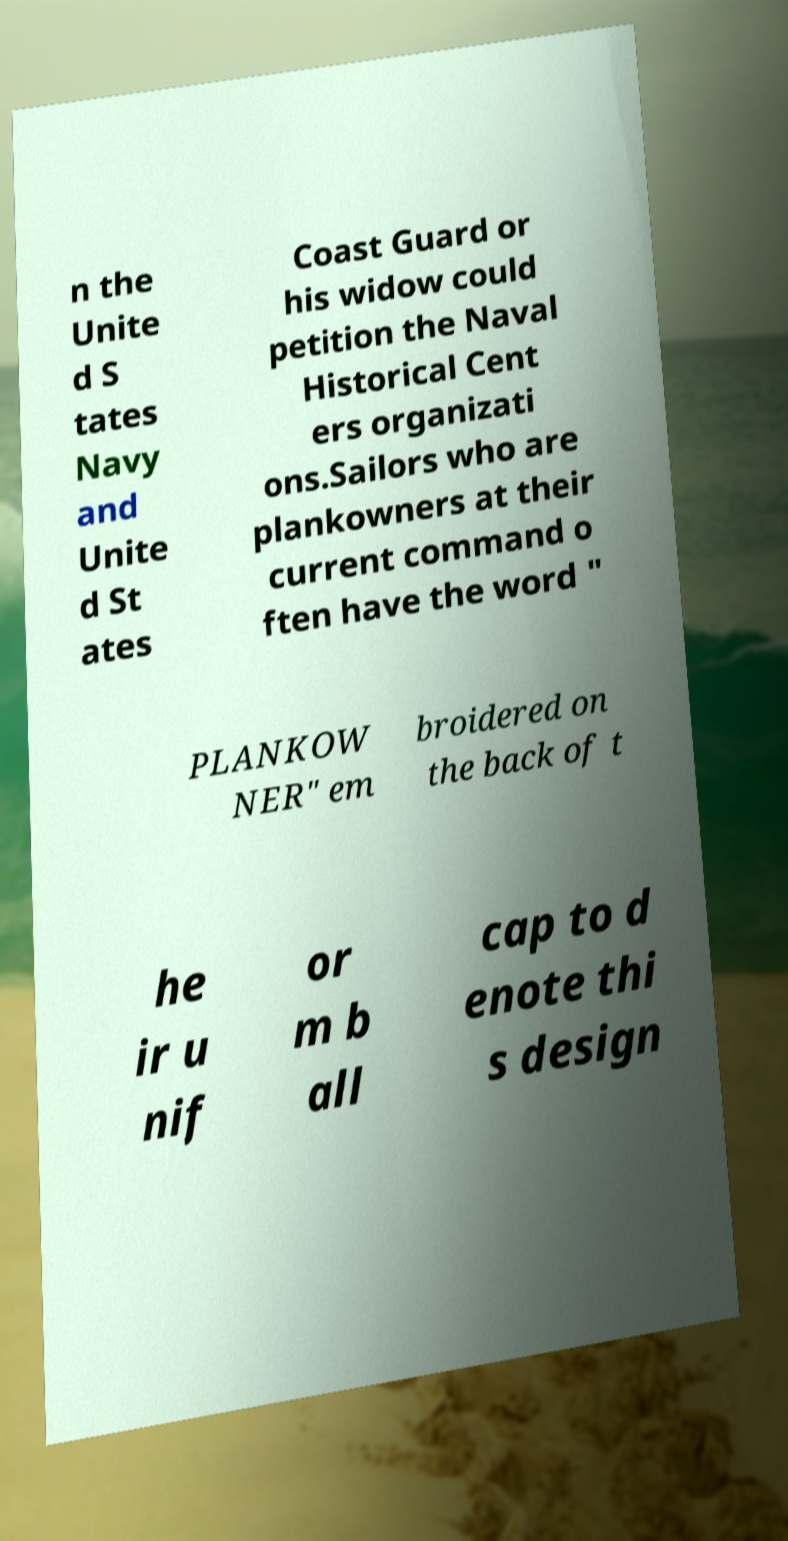Can you read and provide the text displayed in the image?This photo seems to have some interesting text. Can you extract and type it out for me? n the Unite d S tates Navy and Unite d St ates Coast Guard or his widow could petition the Naval Historical Cent ers organizati ons.Sailors who are plankowners at their current command o ften have the word " PLANKOW NER" em broidered on the back of t he ir u nif or m b all cap to d enote thi s design 